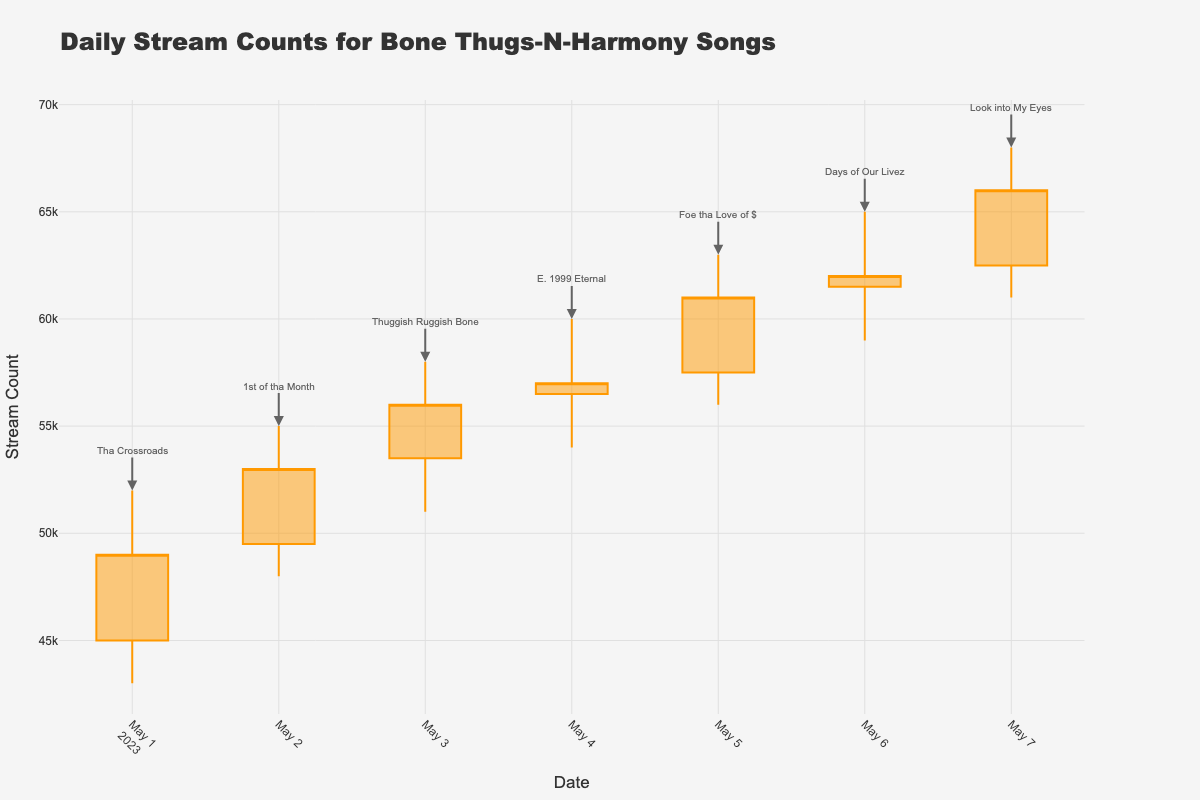What is the title of the chart? The title is displayed at the top of the chart.
Answer: Daily Stream Counts for Bone Thugs-N-Harmony Songs What are the start and end dates covered in this chart? The first date on the x-axis is May 1, 2023, and the last date is May 7, 2023.
Answer: May 1, 2023 to May 7, 2023 Which song has the highest single day stream count, and what is the count? Look at the High values for each day; the song on May 7, 2023, 'Look into My Eyes', has the highest value at 68,000.
Answer: Look into My Eyes, 68,000 What is the low value of daily streams for '1st of tha Month'? Find the row for May 2, 2023, and look at the Low value, which is 48,000.
Answer: 48,000 Which day had the highest close stream count? Look at the Close values for each day; the highest value is 66,000 on May 7, 2023.
Answer: May 7, 2023 What is the total number of stream counts (Open) across all days? Add up all the Open values: 45000 + 49500 + 53500 + 56500 + 57500 + 61500 + 62500 = 386000.
Answer: 386000 Which song experienced the largest intraday range (difference between High and Low)? Calculate the difference between High and Low for each day and find the maximum: Largest difference is 7,000 for 'Look into My Eyes' on May 7, 2023.
Answer: Look into My Eyes Compare the opening and closing stream counts for 'Tha Crossroads'. Did it increase or decrease? Tha Crossroads opened at 45,000 and closed at 49,000, so it increased.
Answer: Increased What's the average closing stream count for all songs during the given week? Calculate the average of the Close values: (49000 + 53000 + 56000 + 57000 + 61000 + 62000 + 66000)/7 = 57643 points approximately.
Answer: 57643 Is there any day where the closing stream count was lower than the opening stream count? Compare Open and Close values for each day: None of the Close values are lower than the Open values.
Answer: No 